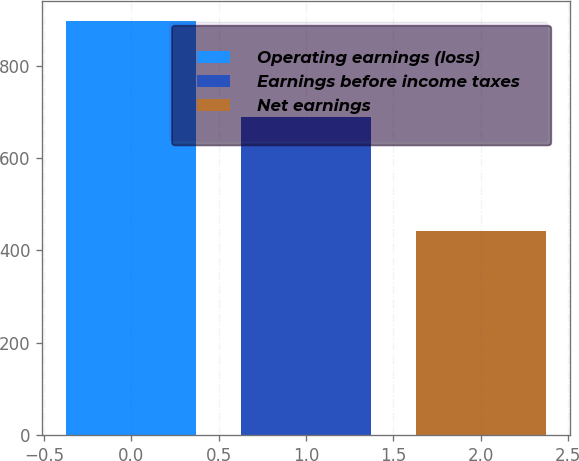Convert chart. <chart><loc_0><loc_0><loc_500><loc_500><bar_chart><fcel>Operating earnings (loss)<fcel>Earnings before income taxes<fcel>Net earnings<nl><fcel>895.7<fcel>687.7<fcel>440.7<nl></chart> 